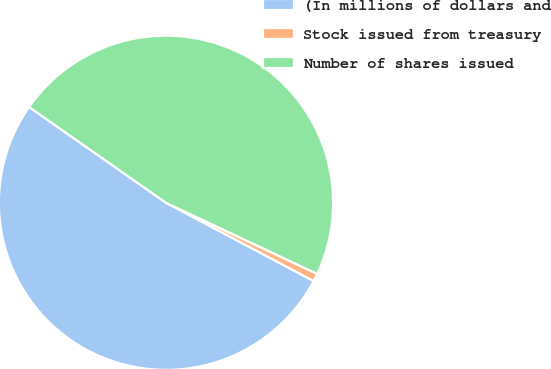Convert chart to OTSL. <chart><loc_0><loc_0><loc_500><loc_500><pie_chart><fcel>(In millions of dollars and<fcel>Stock issued from treasury<fcel>Number of shares issued<nl><fcel>51.96%<fcel>0.76%<fcel>47.29%<nl></chart> 